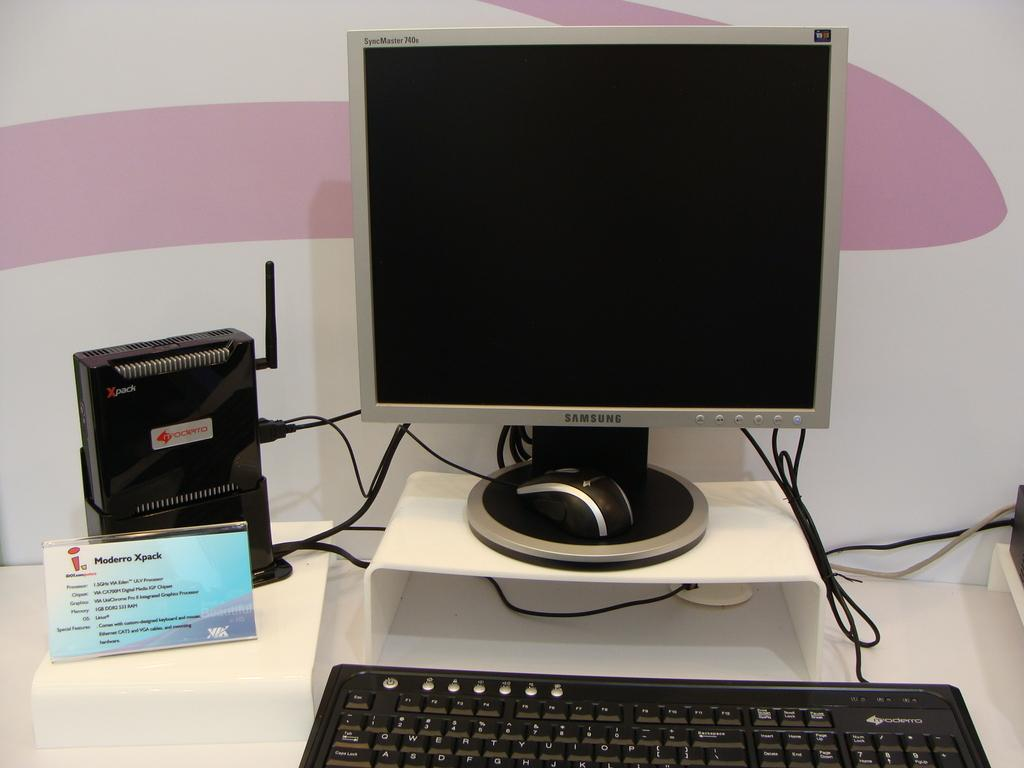<image>
Render a clear and concise summary of the photo. A Samsung computer sits on displays next to a Moderro Xpack 